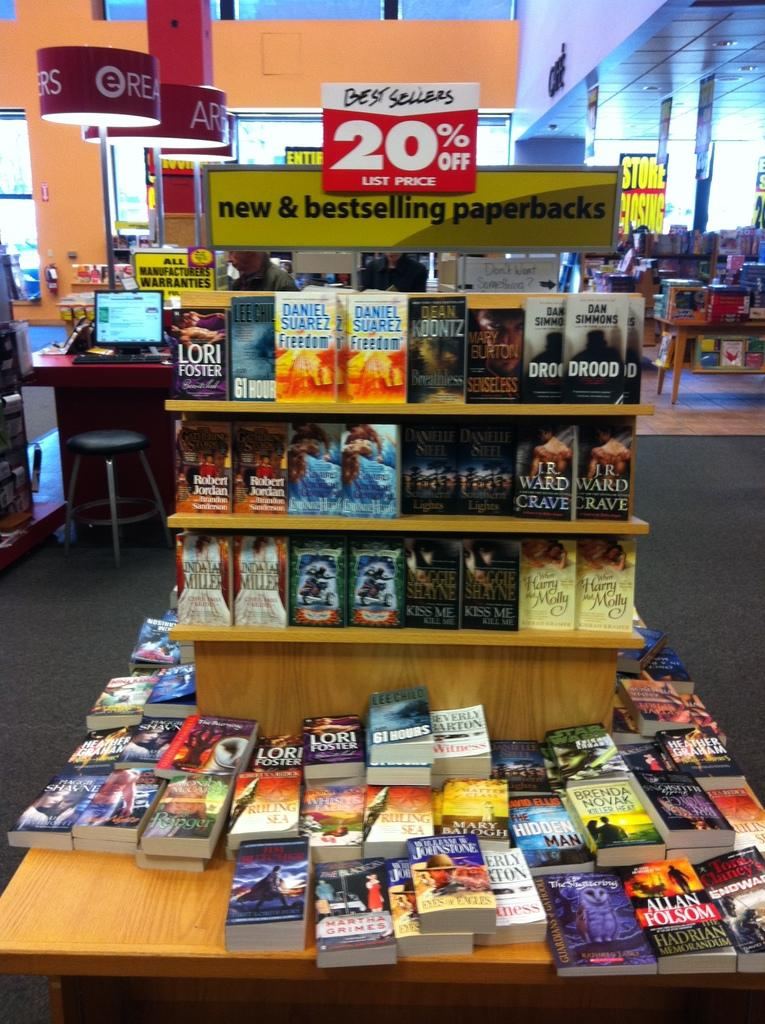<image>
Provide a brief description of the given image. A shelf of Best Sellers in a book store on sale for 20 percent off. 